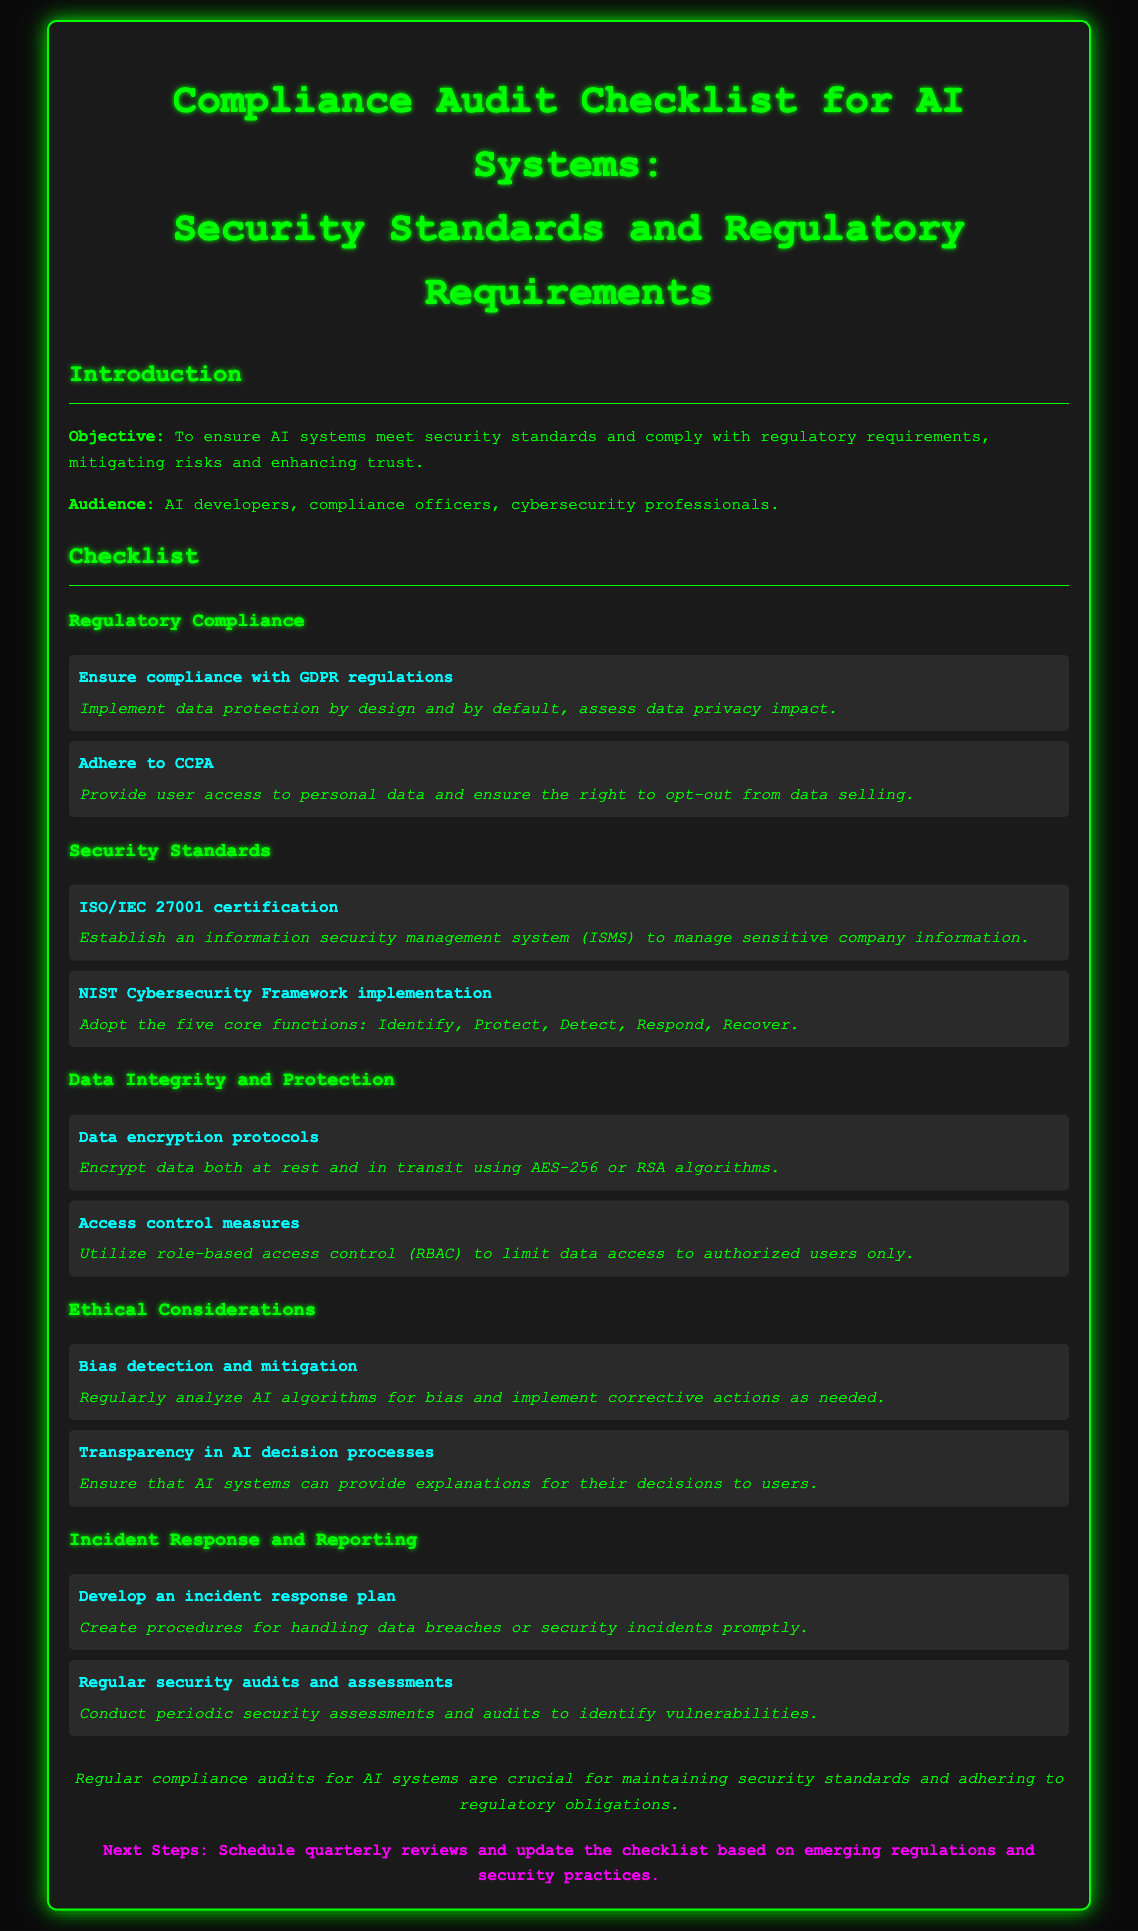What is the objective of the compliance audit checklist? The objective is to ensure AI systems meet security standards and comply with regulatory requirements, mitigating risks and enhancing trust.
Answer: To ensure AI systems meet security standards and comply with regulatory requirements Who is the audience for the document? The audience includes AI developers, compliance officers, and cybersecurity professionals.
Answer: AI developers, compliance officers, cybersecurity professionals What standard must be implemented for ISO/IEC 27001 certification? The requirement is to establish an information security management system (ISMS) to manage sensitive company information.
Answer: Establish an information security management system (ISMS) What encryption protocols are mentioned? The document specifies that data should be encrypted both at rest and in transit using AES-256 or RSA algorithms.
Answer: AES-256 or RSA algorithms What key principle is involved in bias detection and mitigation? The principle involves regularly analyzing AI algorithms for bias and implementing corrective actions as needed.
Answer: Regularly analyze AI algorithms for bias What is a crucial aspect of the incident response plan? The key aspect is to create procedures for handling data breaches or security incidents promptly.
Answer: Create procedures for handling data breaches or security incidents promptly How often should the compliance audit checklist be reviewed? The next steps suggest scheduling quarterly reviews for the checklist.
Answer: Quarterly reviews What is the importance of regular security audits? Regular security audits and assessments are crucial to identify vulnerabilities.
Answer: Identify vulnerabilities What is one of the ethical considerations mentioned? One ethical consideration is ensuring that AI systems can provide explanations for their decisions to users.
Answer: Transparency in AI decision processes 